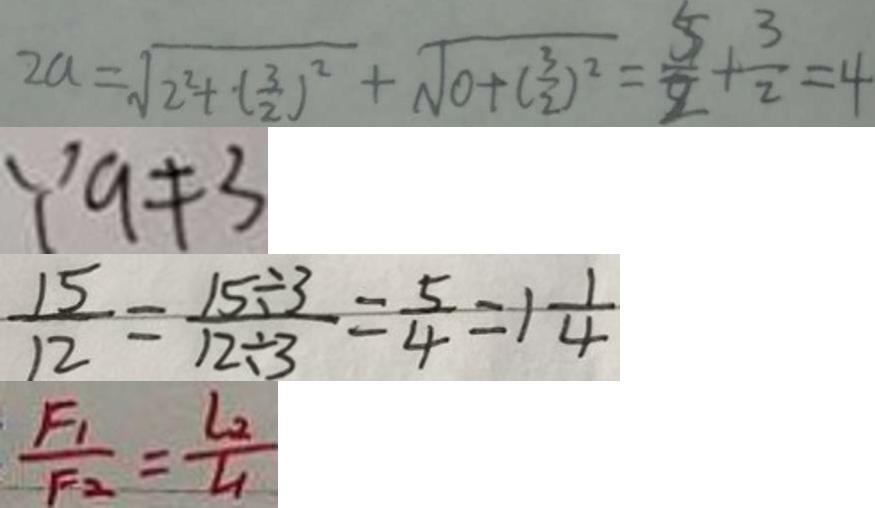<formula> <loc_0><loc_0><loc_500><loc_500>2 a = \sqrt { 2 ^ { 2 } + ( \frac { 3 } { 2 } ) ^ { 2 } } + \sqrt { 0 + ( \frac { 3 } { 2 } ) ^ { 2 } } = \frac { 5 } { 2 } + \frac { 3 } { 2 } = 4 
 \because a \neq 3 
 \frac { 1 5 } { 1 2 } = \frac { 1 5 \div 3 } { 1 2 \div 3 } = \frac { 5 } { 4 } = 1 \frac { 1 } { 4 } 
 \frac { F _ { 1 } } { F _ { 2 } } = \frac { L _ { 2 } } { L _ { 1 } }</formula> 